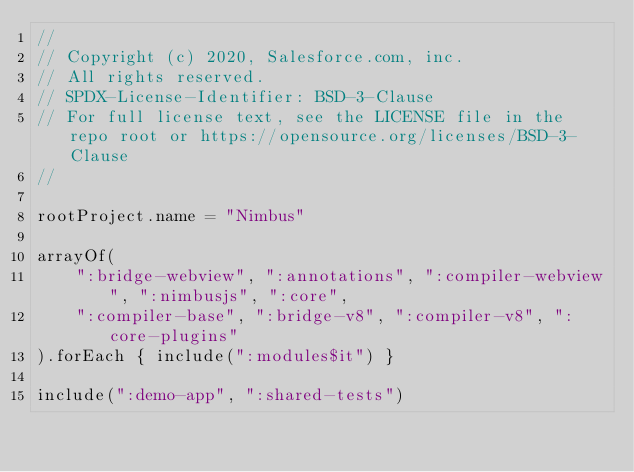Convert code to text. <code><loc_0><loc_0><loc_500><loc_500><_Kotlin_>//
// Copyright (c) 2020, Salesforce.com, inc.
// All rights reserved.
// SPDX-License-Identifier: BSD-3-Clause
// For full license text, see the LICENSE file in the repo root or https://opensource.org/licenses/BSD-3-Clause
//

rootProject.name = "Nimbus"

arrayOf(
    ":bridge-webview", ":annotations", ":compiler-webview", ":nimbusjs", ":core",
    ":compiler-base", ":bridge-v8", ":compiler-v8", ":core-plugins"
).forEach { include(":modules$it") }

include(":demo-app", ":shared-tests")
</code> 